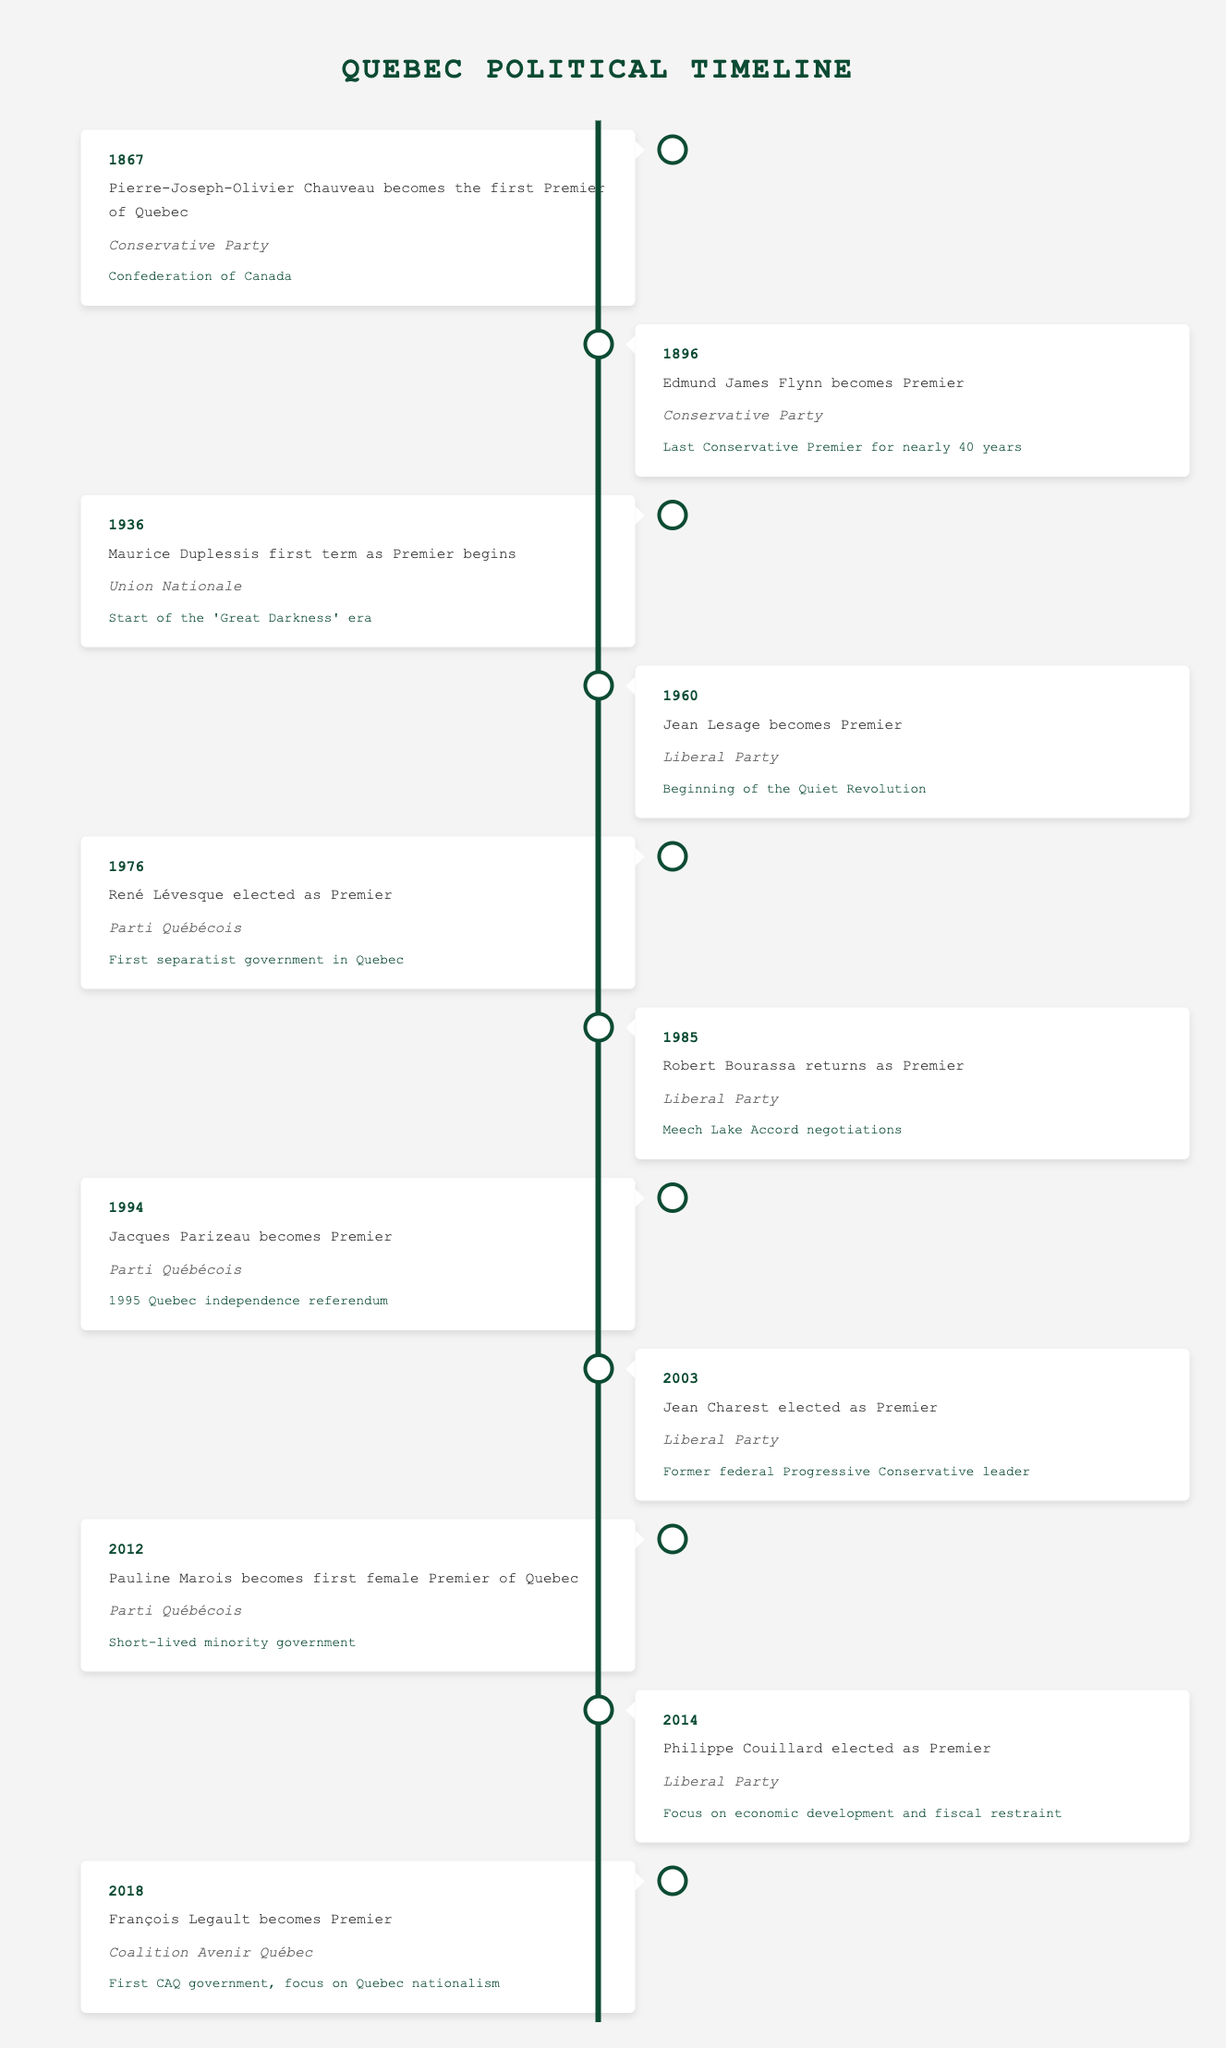What year did Pierre-Joseph-Olivier Chauveau become Premier of Quebec? According to the table, Pierre-Joseph-Olivier Chauveau became Premier in 1867. This can be directly found in the first entry of the timeline.
Answer: 1867 How many political parties are represented by the Premiers listed in the table? By examining the table, we see three different political parties represented: the Conservative Party, the Liberal Party, and the Parti Québécois. Additionally, there is the Union Nationale and the Coalition Avenir Québec. Counting these gives us a total of 5 different parties.
Answer: 5 Who was the Premier of Quebec during the 1995 independence referendum? The table indicates that Jacques Parizeau became Premier in 1994, just before the 1995 Quebec independence referendum. This information is found in the row corresponding to 1994.
Answer: Jacques Parizeau Was there a time when Quebec was governed by a female Premier? Yes, Pauline Marois was the first female Premier of Quebec, according to the entry in the year 2012 in the table. This confirms that there was indeed a time when a female led the province.
Answer: Yes What was the political party of the Premier before François Legault? The Premier before François Legault, who took office in 2018, was Philippe Couillard, who represented the Liberal Party according to the 2014 entry in the timeline.
Answer: Liberal Party Which Premier initiated the Quiet Revolution? The table states that Jean Lesage, who became Premier in 1960, is credited with initiating the Quiet Revolution. This is specifically mentioned next to his entry in the timeline.
Answer: Jean Lesage How many years passed between the first and last entries in the timeline? The first entry is from 1867 and the last entry is from 2018. To find the number of years between these entries, subtract 1867 from 2018: 2018 - 1867 = 151 years.
Answer: 151 years What significant event is linked to René Lévesque’s election? According to the table, René Lévesque’s election in 1976 marks the beginning of the first separatist government in Quebec, as noted in the significance section of his entry.
Answer: First separatist government in Quebec What is the total number of Liberal Party Premiers from the timeline? From the table, the Liberal Party had a total of three Premiers: Jean Lesage (1960), Robert Bourassa (1985), and Jean Charest (2003). By counting these entries, we determine the total number of Liberal Party Premiers.
Answer: 3 